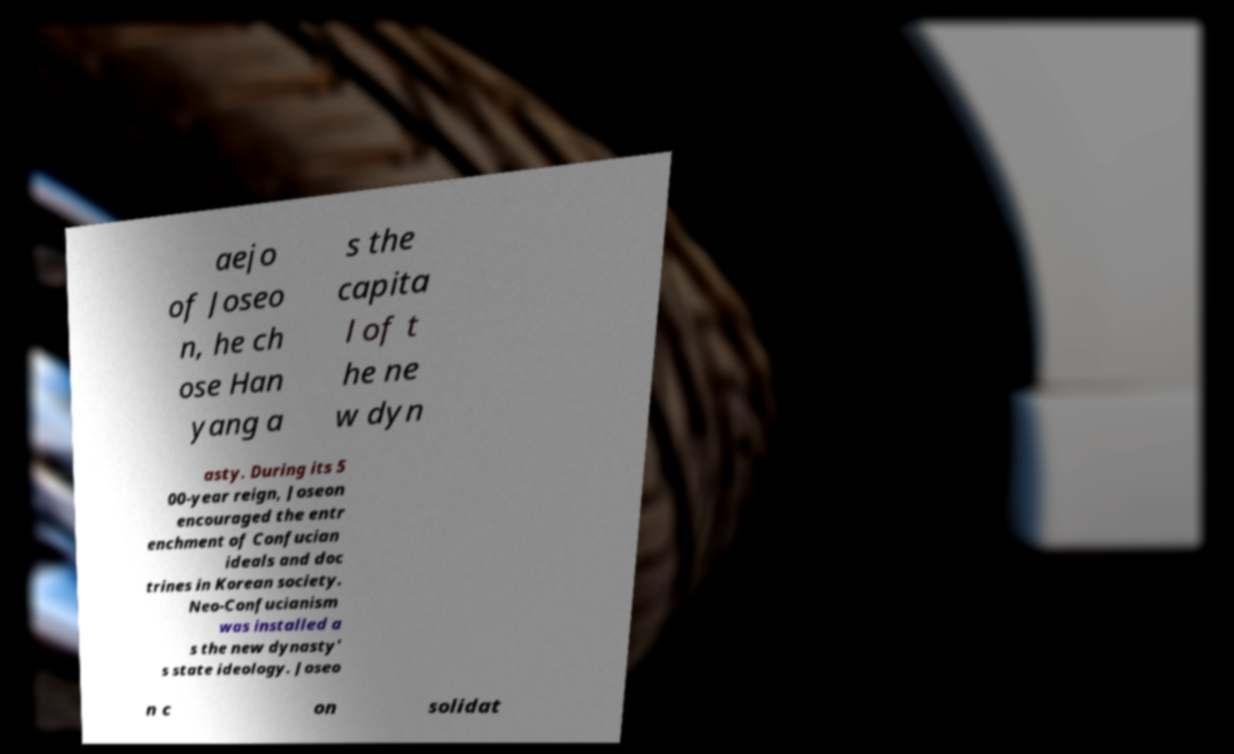There's text embedded in this image that I need extracted. Can you transcribe it verbatim? aejo of Joseo n, he ch ose Han yang a s the capita l of t he ne w dyn asty. During its 5 00-year reign, Joseon encouraged the entr enchment of Confucian ideals and doc trines in Korean society. Neo-Confucianism was installed a s the new dynasty' s state ideology. Joseo n c on solidat 